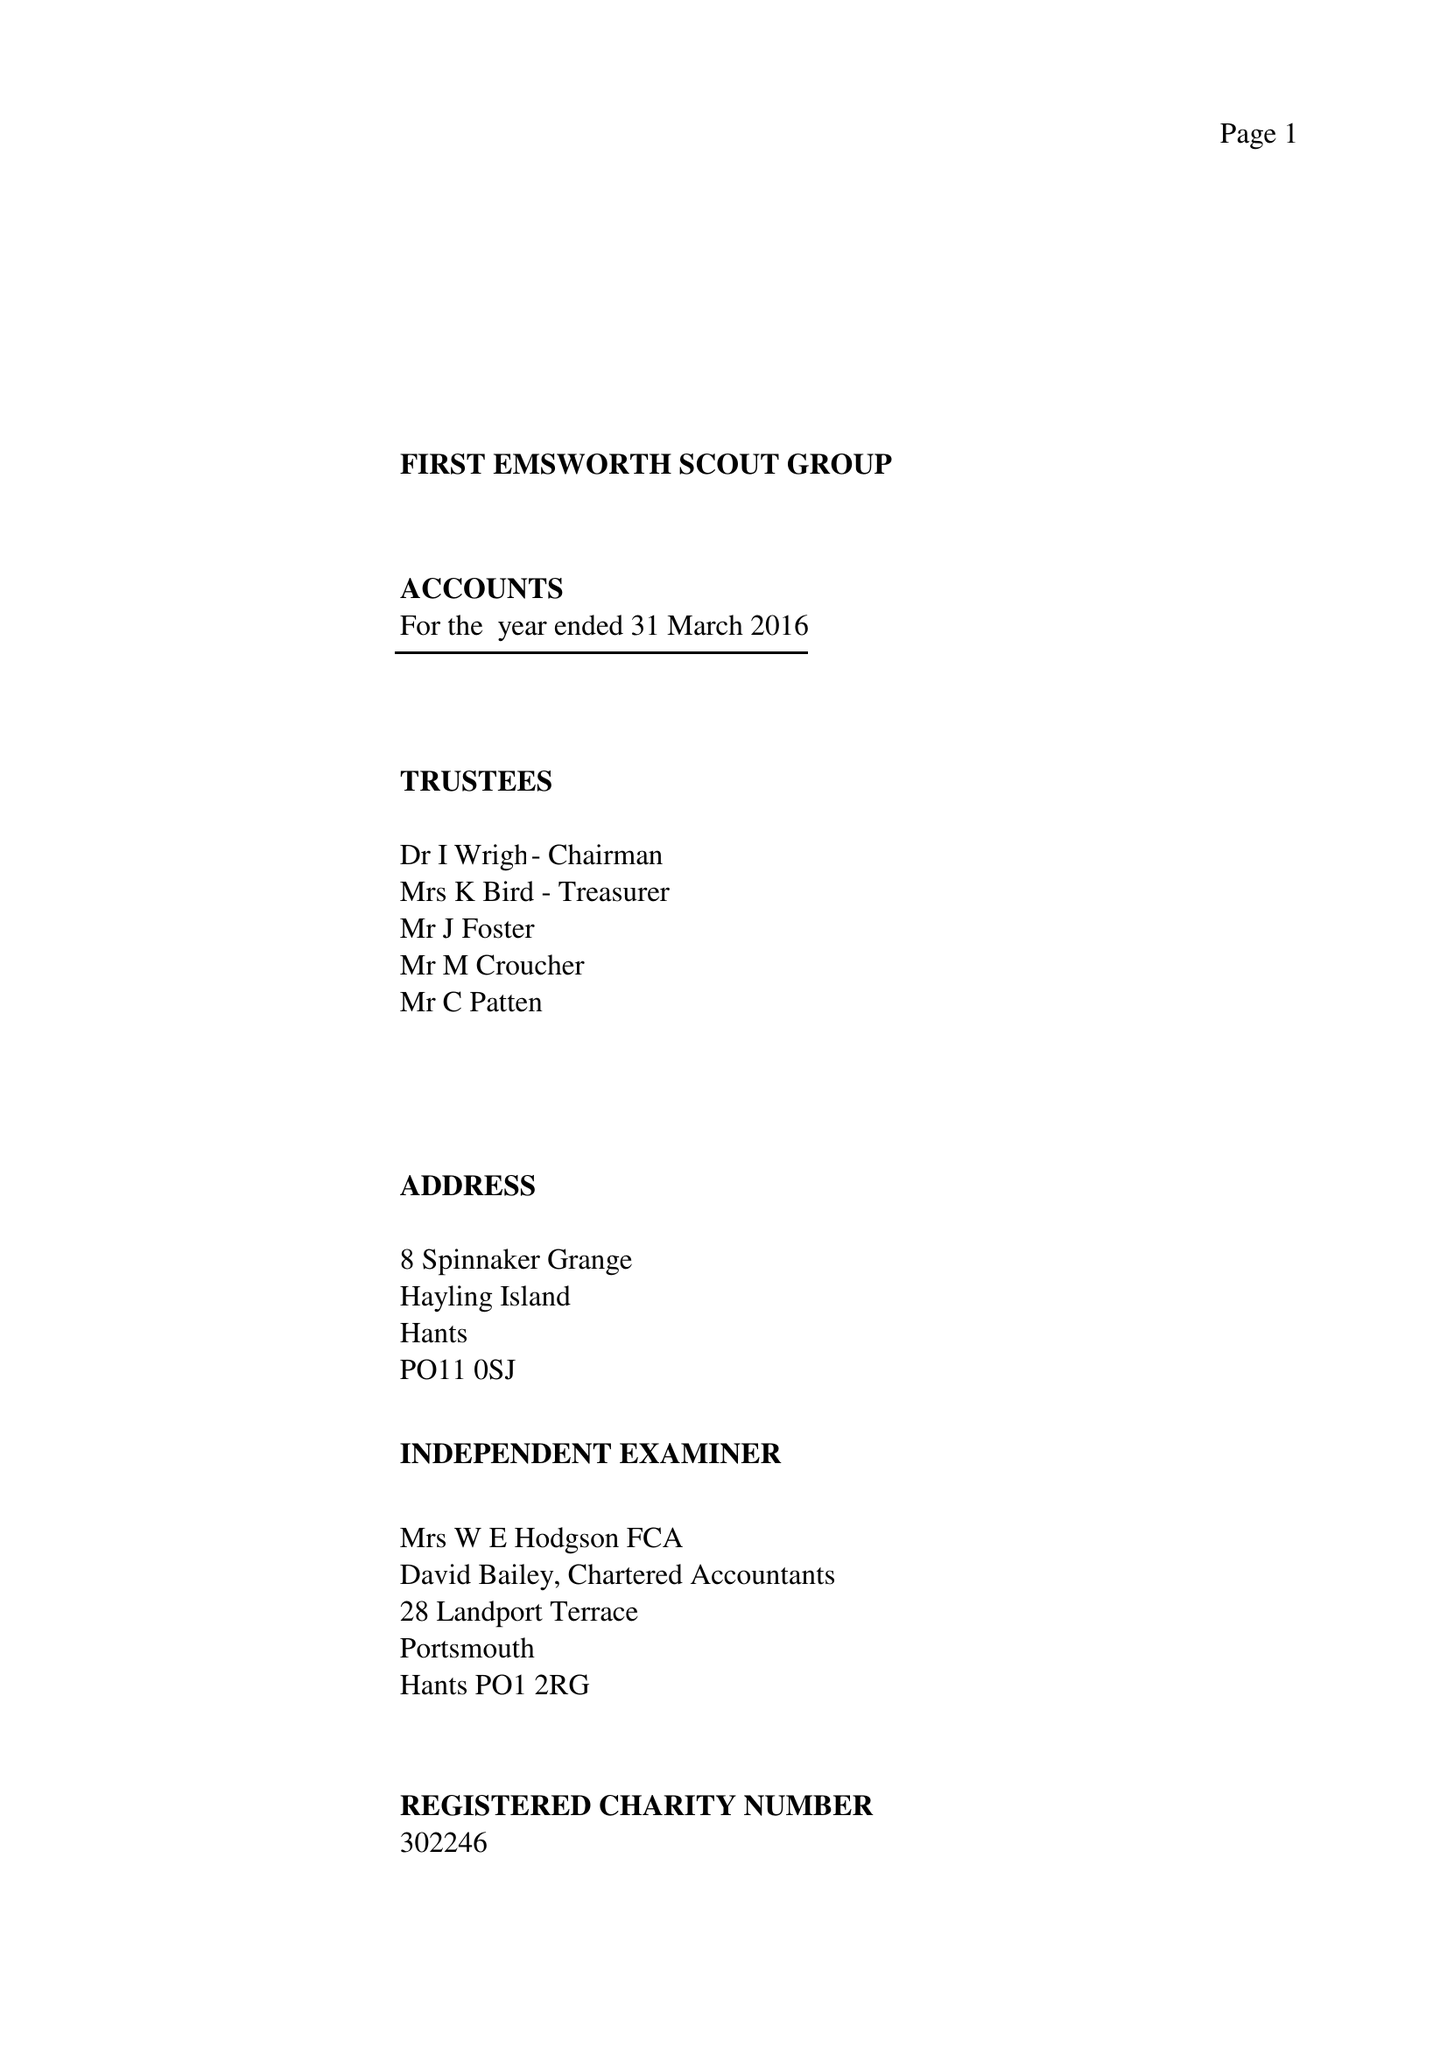What is the value for the spending_annually_in_british_pounds?
Answer the question using a single word or phrase. 31313.00 